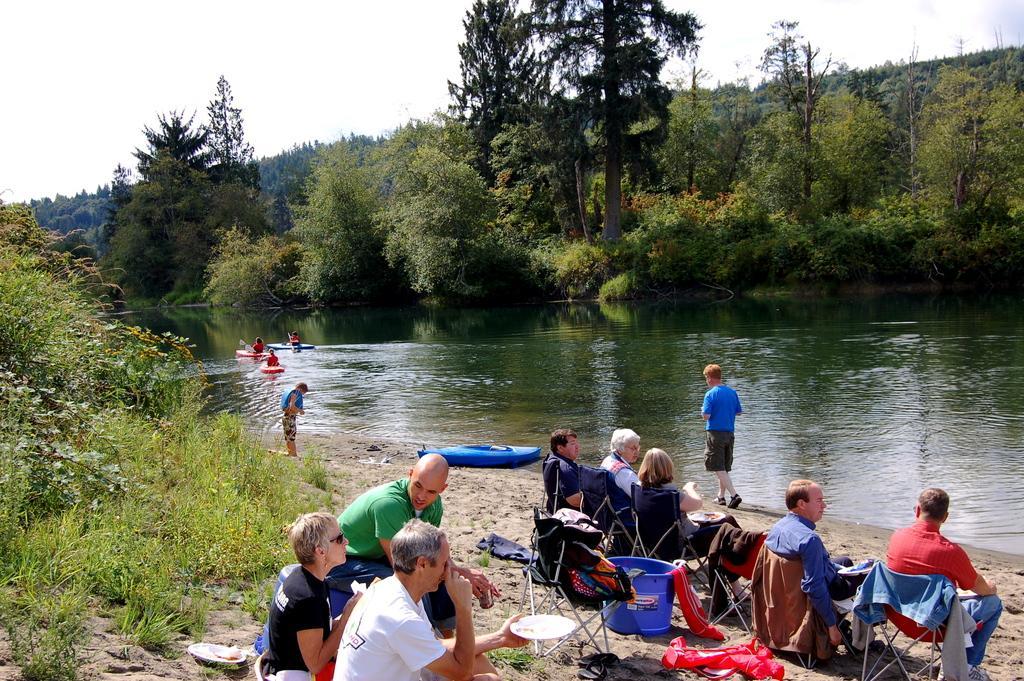Could you give a brief overview of what you see in this image? There are few persons sitting on the chairs. Here we can see clothes, plates, and a tub. This is water and there is a boat. Here we can see two persons are standing and there are three persons on the boats. This is grass and there are plants. In the background we can see trees, and sky. 